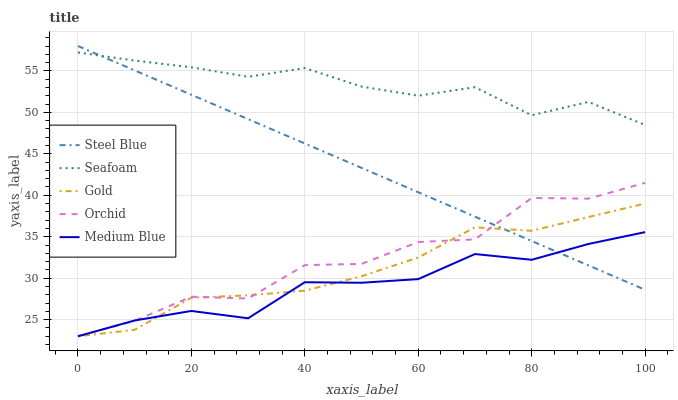Does Medium Blue have the minimum area under the curve?
Answer yes or no. Yes. Does Seafoam have the maximum area under the curve?
Answer yes or no. Yes. Does Steel Blue have the minimum area under the curve?
Answer yes or no. No. Does Steel Blue have the maximum area under the curve?
Answer yes or no. No. Is Steel Blue the smoothest?
Answer yes or no. Yes. Is Orchid the roughest?
Answer yes or no. Yes. Is Medium Blue the smoothest?
Answer yes or no. No. Is Medium Blue the roughest?
Answer yes or no. No. Does Orchid have the lowest value?
Answer yes or no. Yes. Does Steel Blue have the lowest value?
Answer yes or no. No. Does Steel Blue have the highest value?
Answer yes or no. Yes. Does Medium Blue have the highest value?
Answer yes or no. No. Is Gold less than Seafoam?
Answer yes or no. Yes. Is Seafoam greater than Orchid?
Answer yes or no. Yes. Does Orchid intersect Steel Blue?
Answer yes or no. Yes. Is Orchid less than Steel Blue?
Answer yes or no. No. Is Orchid greater than Steel Blue?
Answer yes or no. No. Does Gold intersect Seafoam?
Answer yes or no. No. 